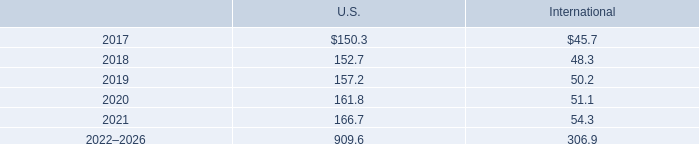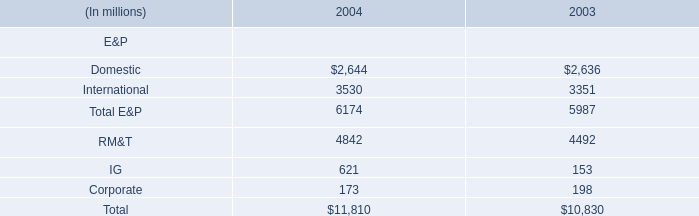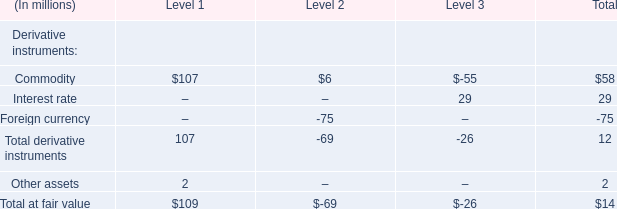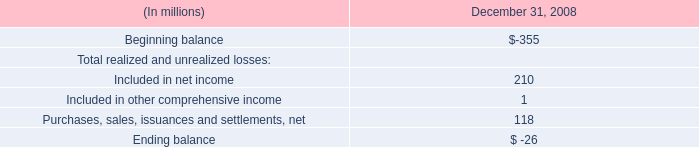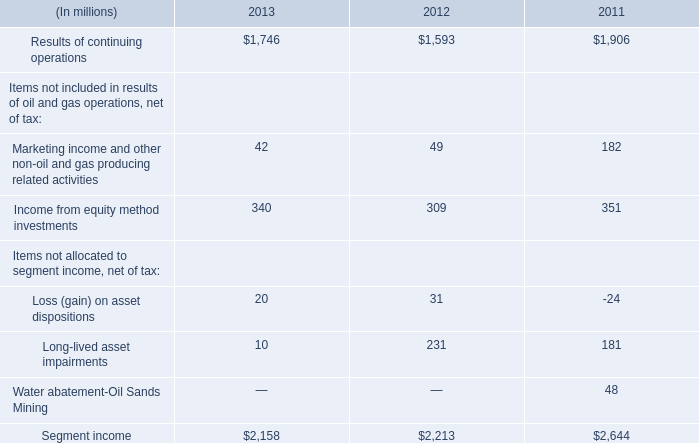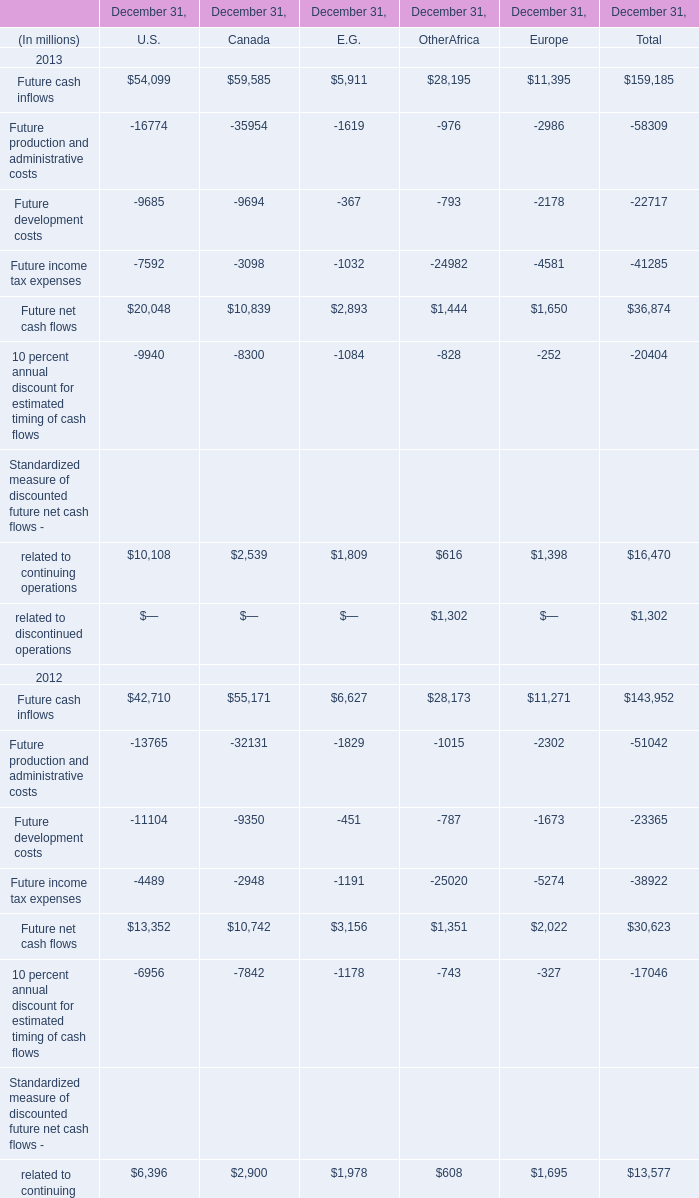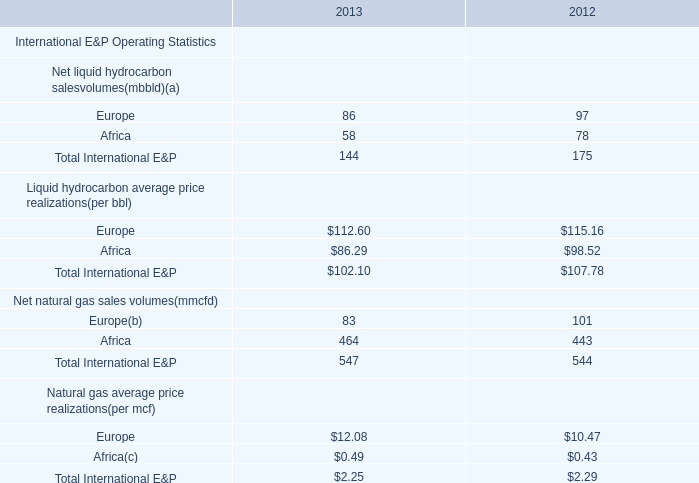What is the sum of Future net cash flows 2011 of December 31, Canada, and Results of continuing operations of 2013 ? 
Computations: (16481.0 + 1746.0)
Answer: 18227.0. 